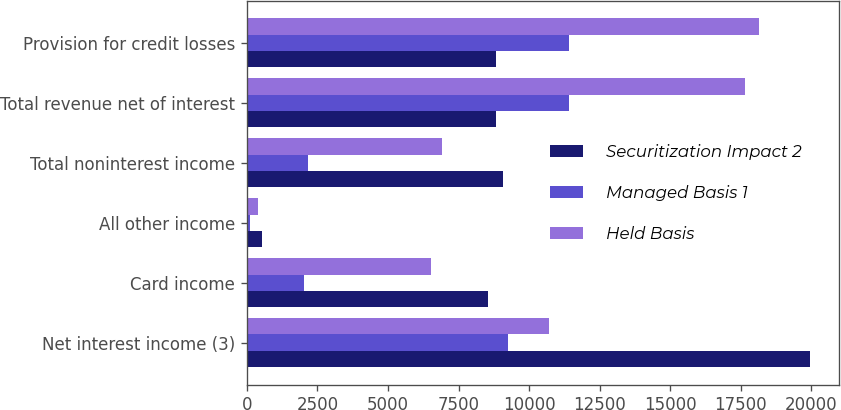Convert chart to OTSL. <chart><loc_0><loc_0><loc_500><loc_500><stacked_bar_chart><ecel><fcel>Net interest income (3)<fcel>Card income<fcel>All other income<fcel>Total noninterest income<fcel>Total revenue net of interest<fcel>Provision for credit losses<nl><fcel>Securitization Impact 2<fcel>19972<fcel>8553<fcel>521<fcel>9074<fcel>8813.5<fcel>8813.5<nl><fcel>Managed Basis 1<fcel>9250<fcel>2034<fcel>115<fcel>2149<fcel>11399<fcel>11399<nl><fcel>Held Basis<fcel>10722<fcel>6519<fcel>406<fcel>6925<fcel>17647<fcel>18154<nl></chart> 